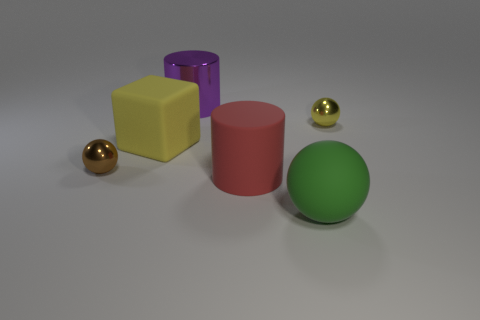Add 2 large yellow metallic cylinders. How many objects exist? 8 Subtract all blocks. How many objects are left? 5 Add 5 green rubber balls. How many green rubber balls are left? 6 Add 2 gray rubber cylinders. How many gray rubber cylinders exist? 2 Subtract 0 red blocks. How many objects are left? 6 Subtract all large yellow matte objects. Subtract all red cylinders. How many objects are left? 4 